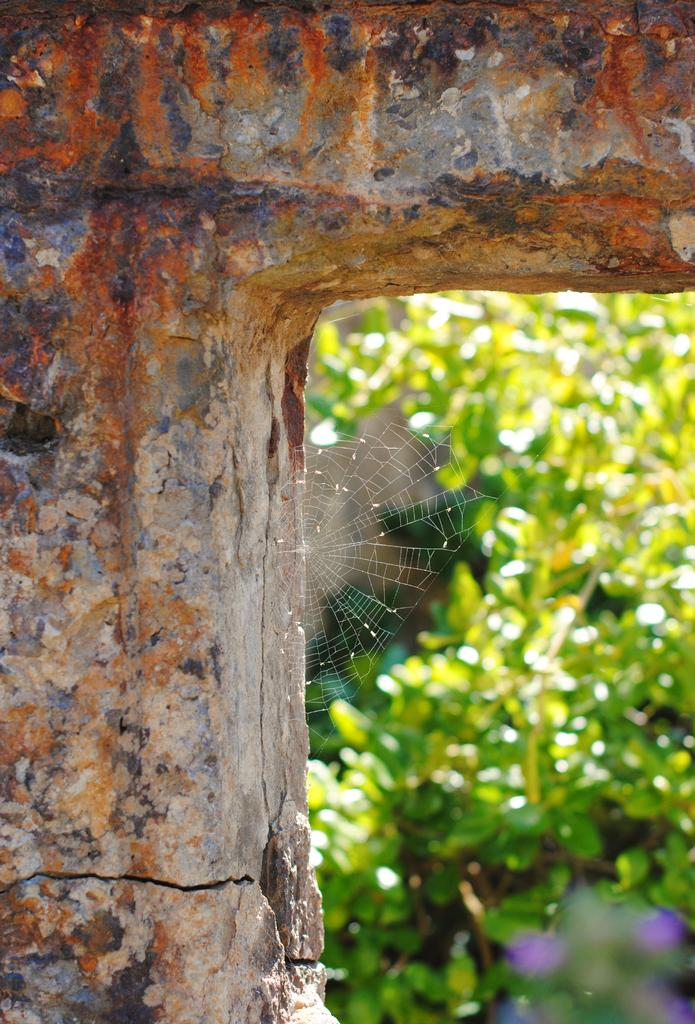What is the main structure in the image? There is a pillar in the image. What is attached to the pillar? There is a spider web in the image. What can be seen in the background of the image? There are plants in the background of the image. How is the background of the image depicted? The background of the image is blurred. How many brothers are depicted in the image? There are no brothers present in the image; it features a pillar with a spider web and plants in the background. What type of lock is used to secure the wrist in the image? There is no wrist or lock present in the image. 